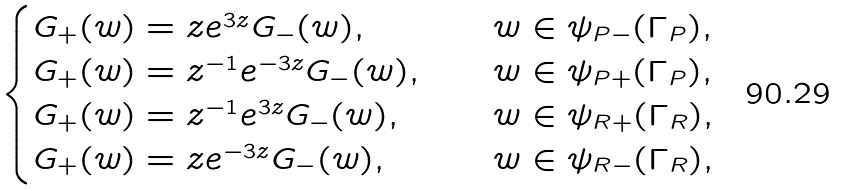<formula> <loc_0><loc_0><loc_500><loc_500>\begin{cases} G _ { + } ( w ) = z e ^ { 3 z } G _ { - } ( w ) , & \quad w \in \psi _ { P - } ( \Gamma _ { P } ) , \\ G _ { + } ( w ) = z ^ { - 1 } e ^ { - 3 z } G _ { - } ( w ) , & \quad w \in \psi _ { P + } ( \Gamma _ { P } ) , \\ G _ { + } ( w ) = z ^ { - 1 } e ^ { 3 z } G _ { - } ( w ) , & \quad w \in \psi _ { R + } ( \Gamma _ { R } ) , \\ G _ { + } ( w ) = z e ^ { - 3 z } G _ { - } ( w ) , & \quad w \in \psi _ { R - } ( \Gamma _ { R } ) , \end{cases}</formula> 